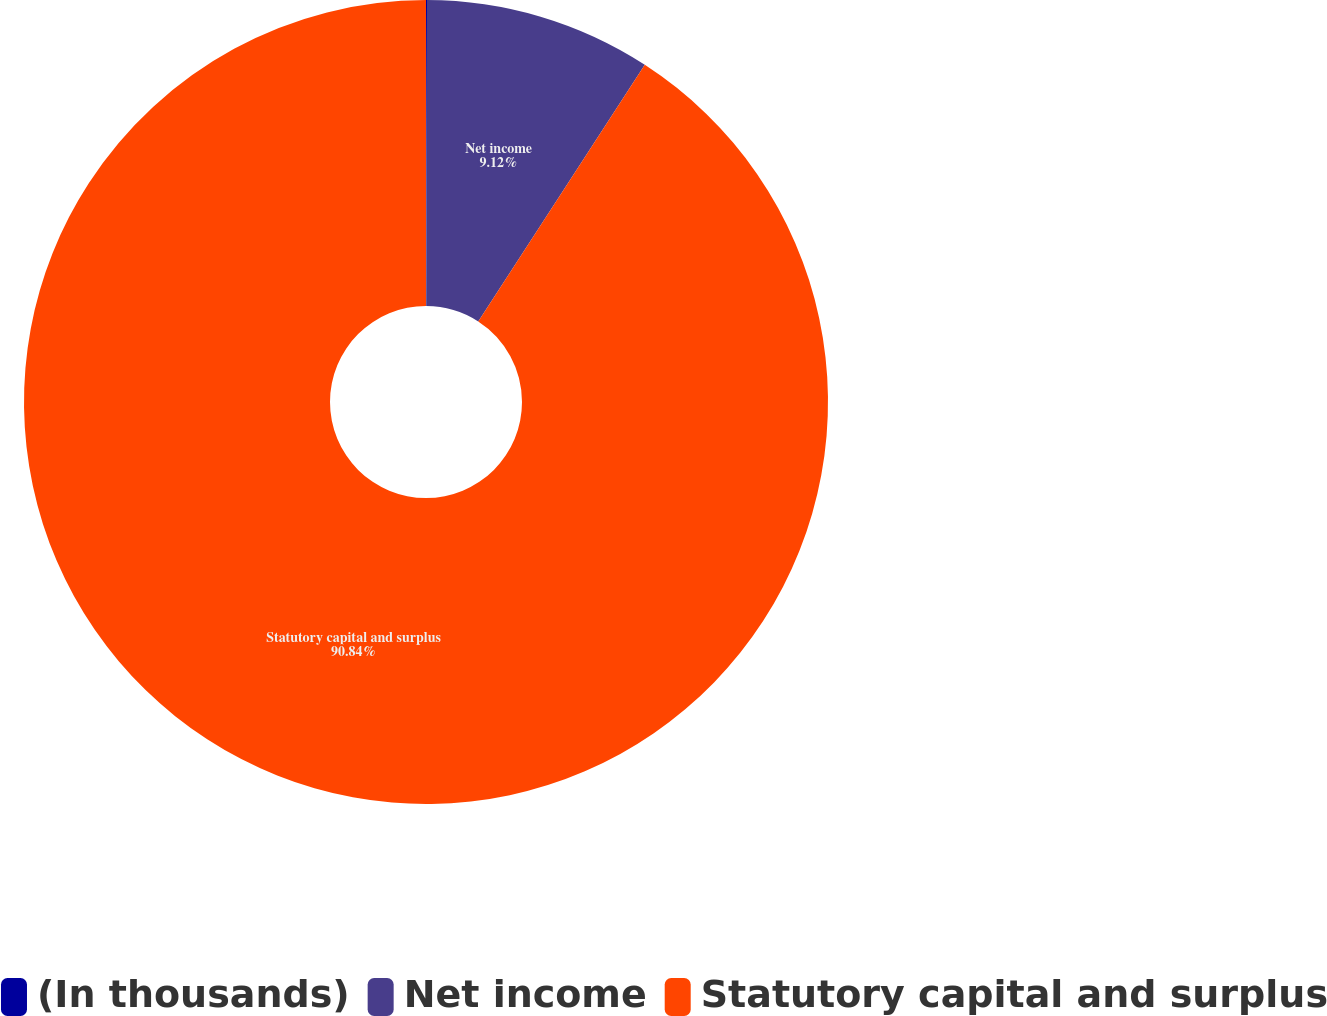Convert chart to OTSL. <chart><loc_0><loc_0><loc_500><loc_500><pie_chart><fcel>(In thousands)<fcel>Net income<fcel>Statutory capital and surplus<nl><fcel>0.04%<fcel>9.12%<fcel>90.84%<nl></chart> 